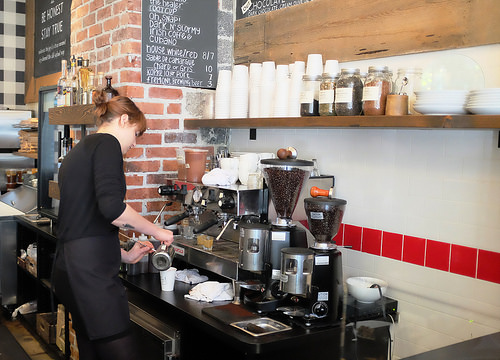<image>
Is the blackboard behind the coffee beans? Yes. From this viewpoint, the blackboard is positioned behind the coffee beans, with the coffee beans partially or fully occluding the blackboard. 